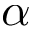Convert formula to latex. <formula><loc_0><loc_0><loc_500><loc_500>\alpha</formula> 